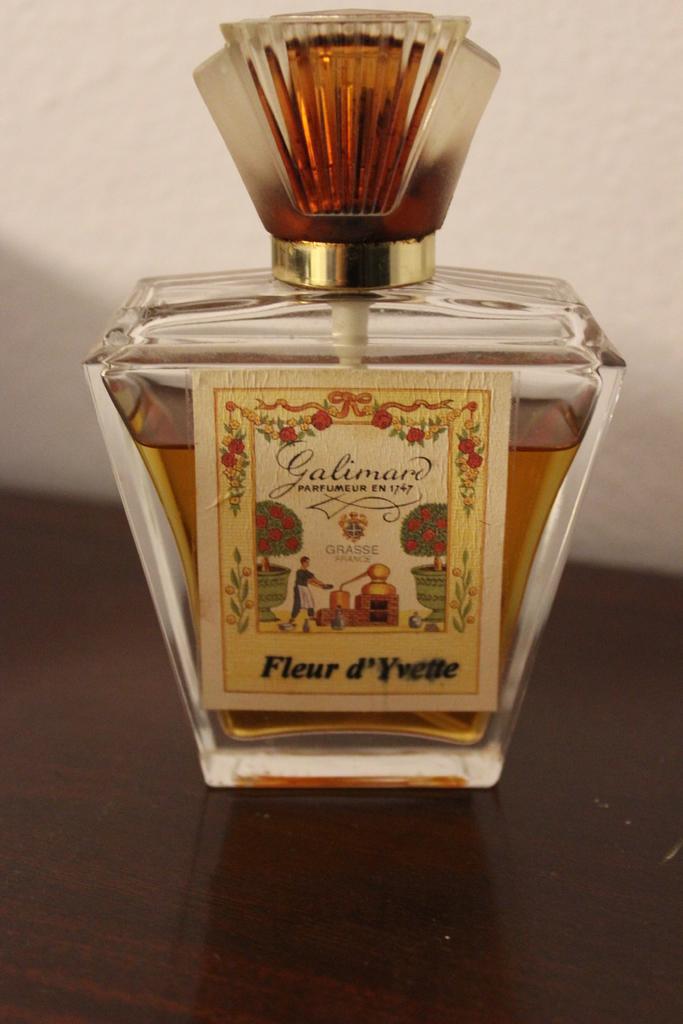What is the brand name here?
Ensure brevity in your answer.  Galimard. 